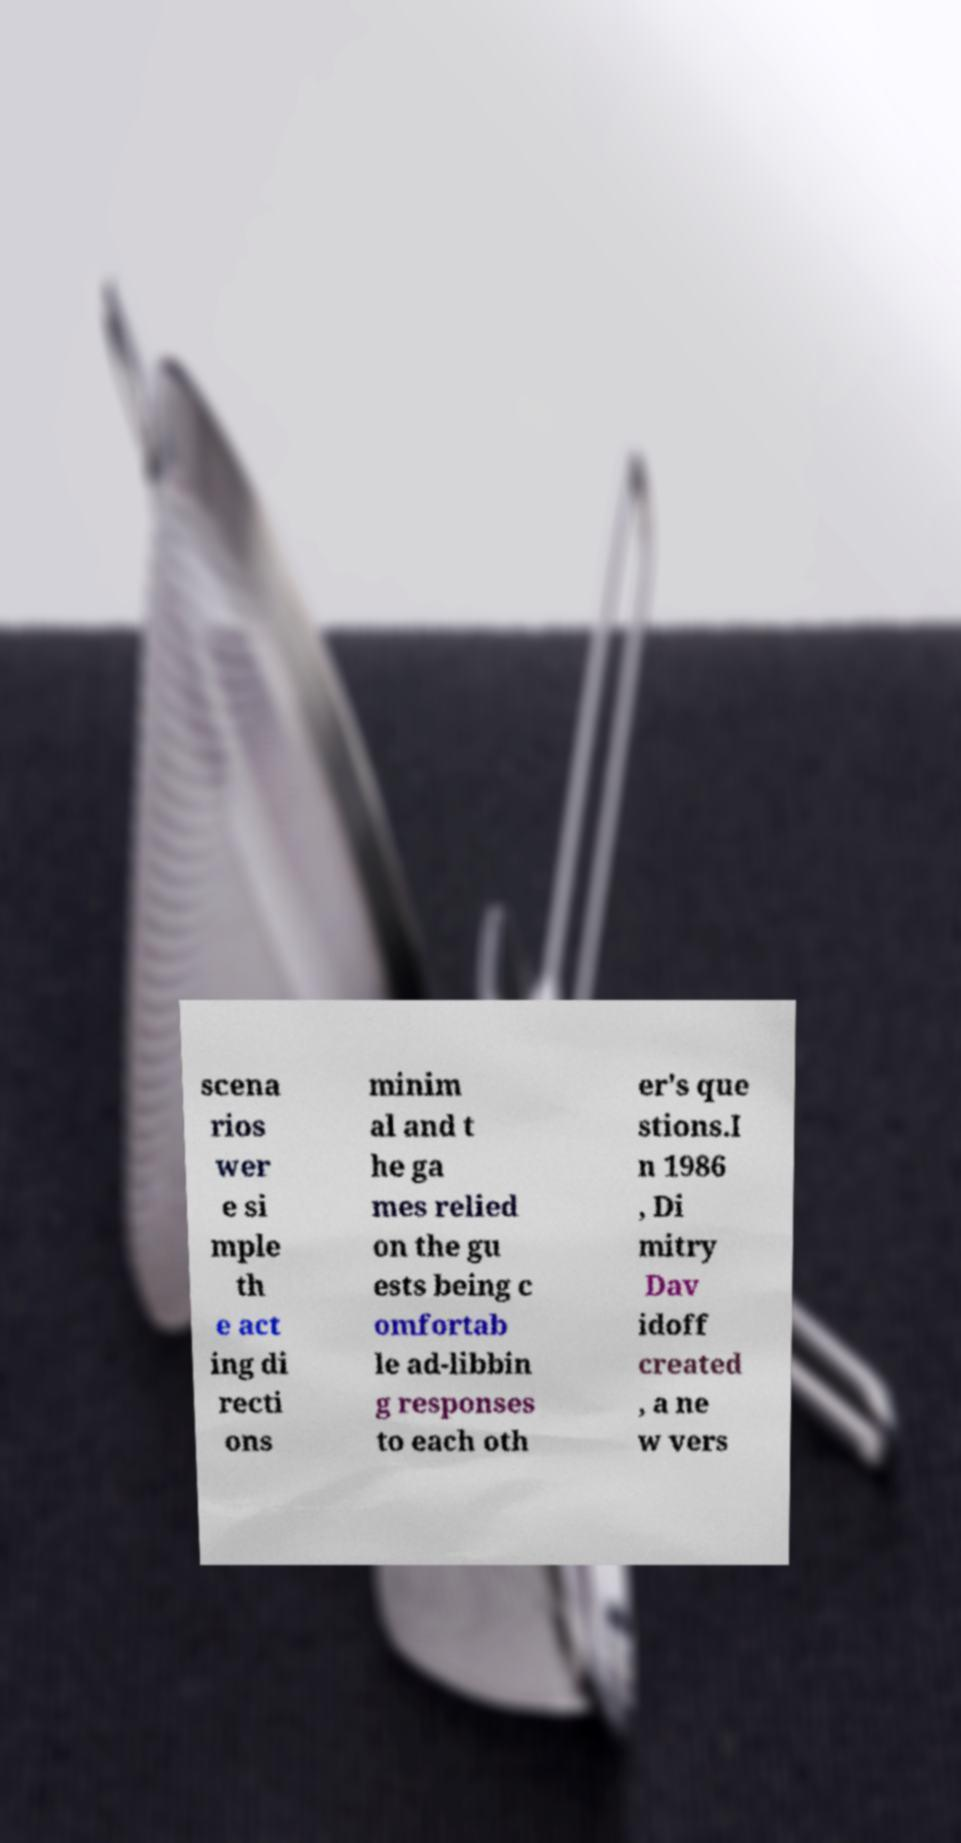Please identify and transcribe the text found in this image. scena rios wer e si mple th e act ing di recti ons minim al and t he ga mes relied on the gu ests being c omfortab le ad-libbin g responses to each oth er's que stions.I n 1986 , Di mitry Dav idoff created , a ne w vers 